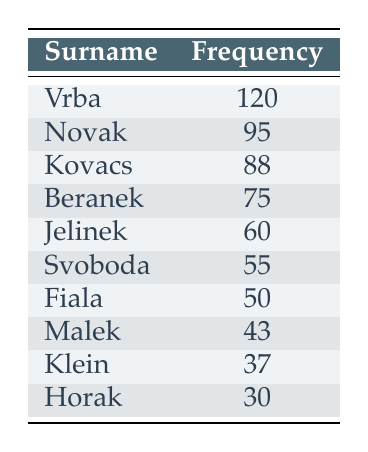What is the frequency of the surname Vrba? The surname Vrba has a frequency of 120, which is directly provided in the table.
Answer: 120 Which surname has the highest frequency? The surname Vrba has the highest frequency at 120, as indicated by the first entry in the table.
Answer: Vrba Is the frequency of the surname Jelinek greater than 50? The frequency of the surname Jelinek is 60, which is greater than 50 as shown in the table.
Answer: Yes What is the total frequency of the top three surnames? To find the total frequency of the top three surnames, add the frequencies of Vrba (120), Novak (95), and Kovacs (88): 120 + 95 + 88 = 303.
Answer: 303 How many surnames have a frequency greater than 50? The surnames with a frequency greater than 50 are Vrba (120), Novak (95), Kovacs (88), Jelinek (60), Svoboda (55), and Fiala (50). That makes 6 surnames in total.
Answer: 6 What is the difference in frequency between the surname Fiala and the surname Horak? The frequency of Fiala is 50 and the frequency of Horak is 30. The difference is 50 - 30 = 20.
Answer: 20 Are there more surnames with a frequency below 50 than above? The surnames with a frequency below 50 are Malek (43), Klein (37), and Horak (30), totaling 3 surnames. The surnames above 50 are Vrba, Novak, Kovacs, Beranek, Jelinek, Svoboda, and Fiala, totaling 7 surnames. Thus, there are more surnames above 50 than below.
Answer: No What is the average frequency of the surnames listed? To find the average, sum all the frequencies: (120 + 95 + 88 + 75 + 60 + 55 + 50 + 43 + 37 + 30) = 703. There are 10 surnames, so the average is 703 / 10 = 70.3.
Answer: 70.3 